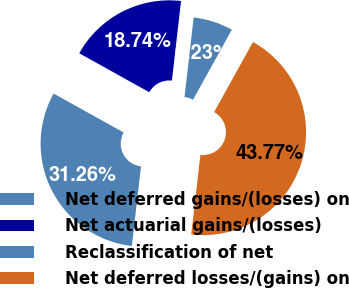Convert chart to OTSL. <chart><loc_0><loc_0><loc_500><loc_500><pie_chart><fcel>Net deferred gains/(losses) on<fcel>Net actuarial gains/(losses)<fcel>Reclassification of net<fcel>Net deferred losses/(gains) on<nl><fcel>6.23%<fcel>18.74%<fcel>31.26%<fcel>43.77%<nl></chart> 